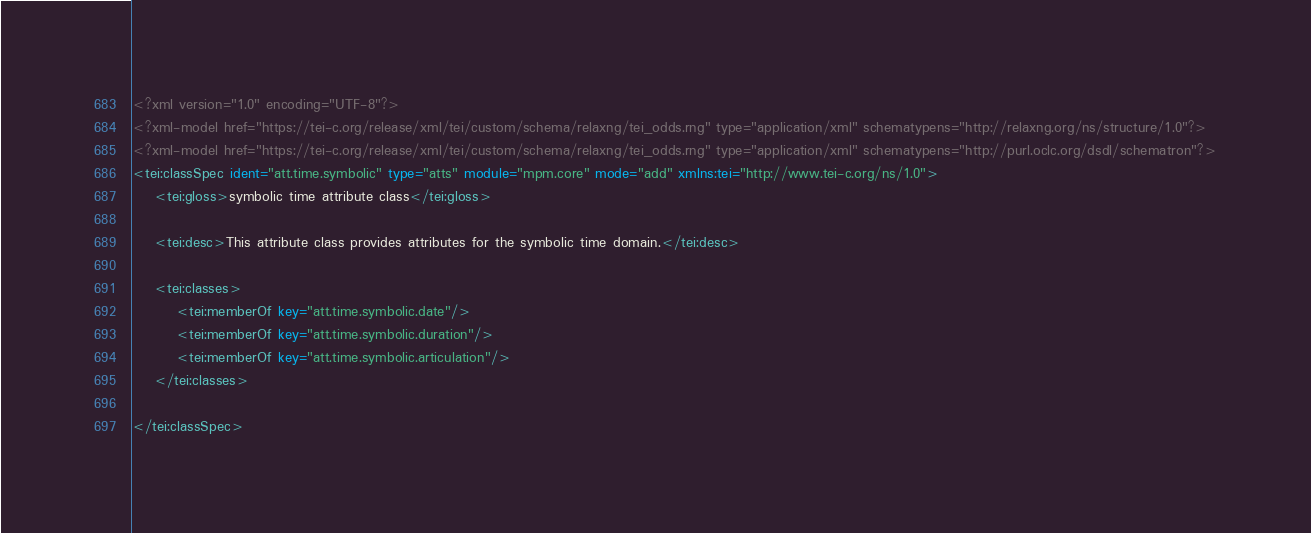<code> <loc_0><loc_0><loc_500><loc_500><_XML_><?xml version="1.0" encoding="UTF-8"?>
<?xml-model href="https://tei-c.org/release/xml/tei/custom/schema/relaxng/tei_odds.rng" type="application/xml" schematypens="http://relaxng.org/ns/structure/1.0"?>
<?xml-model href="https://tei-c.org/release/xml/tei/custom/schema/relaxng/tei_odds.rng" type="application/xml" schematypens="http://purl.oclc.org/dsdl/schematron"?>
<tei:classSpec ident="att.time.symbolic" type="atts" module="mpm.core" mode="add" xmlns:tei="http://www.tei-c.org/ns/1.0">
    <tei:gloss>symbolic time attribute class</tei:gloss>
    
    <tei:desc>This attribute class provides attributes for the symbolic time domain.</tei:desc>

    <tei:classes>
        <tei:memberOf key="att.time.symbolic.date"/>
        <tei:memberOf key="att.time.symbolic.duration"/>
        <tei:memberOf key="att.time.symbolic.articulation"/>
    </tei:classes>

</tei:classSpec>
</code> 